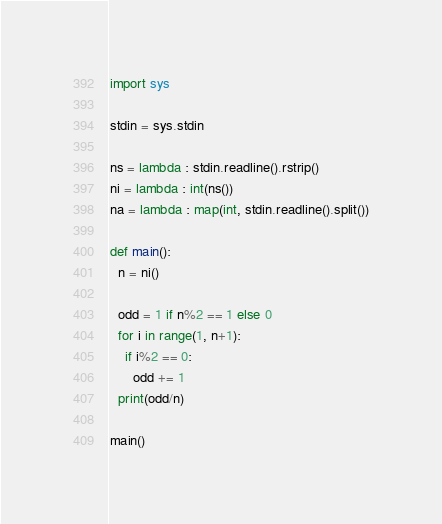Convert code to text. <code><loc_0><loc_0><loc_500><loc_500><_Python_>import sys

stdin = sys.stdin

ns = lambda : stdin.readline().rstrip()
ni = lambda : int(ns())
na = lambda : map(int, stdin.readline().split())

def main():
  n = ni()

  odd = 1 if n%2 == 1 else 0
  for i in range(1, n+1):
    if i%2 == 0:
      odd += 1
  print(odd/n)

main()</code> 